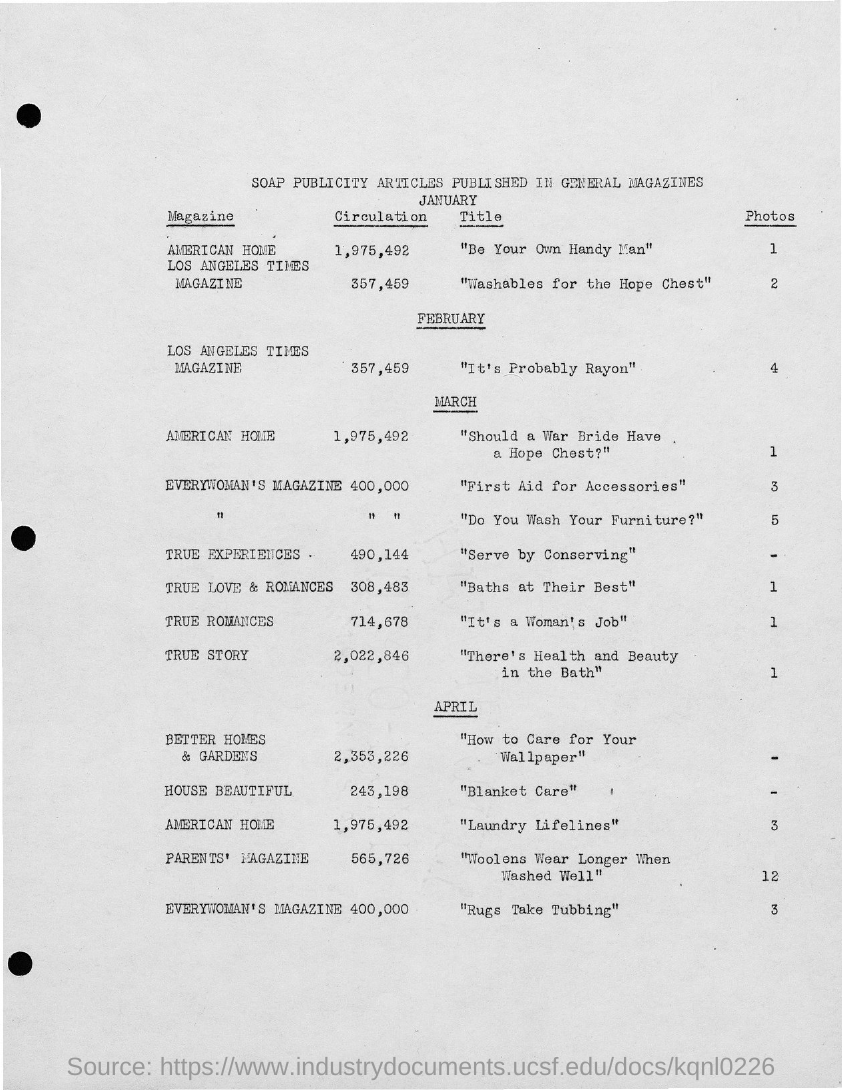Outline some significant characteristics in this image. The document is titled "Soap Publicity articles published in General Magazines. 